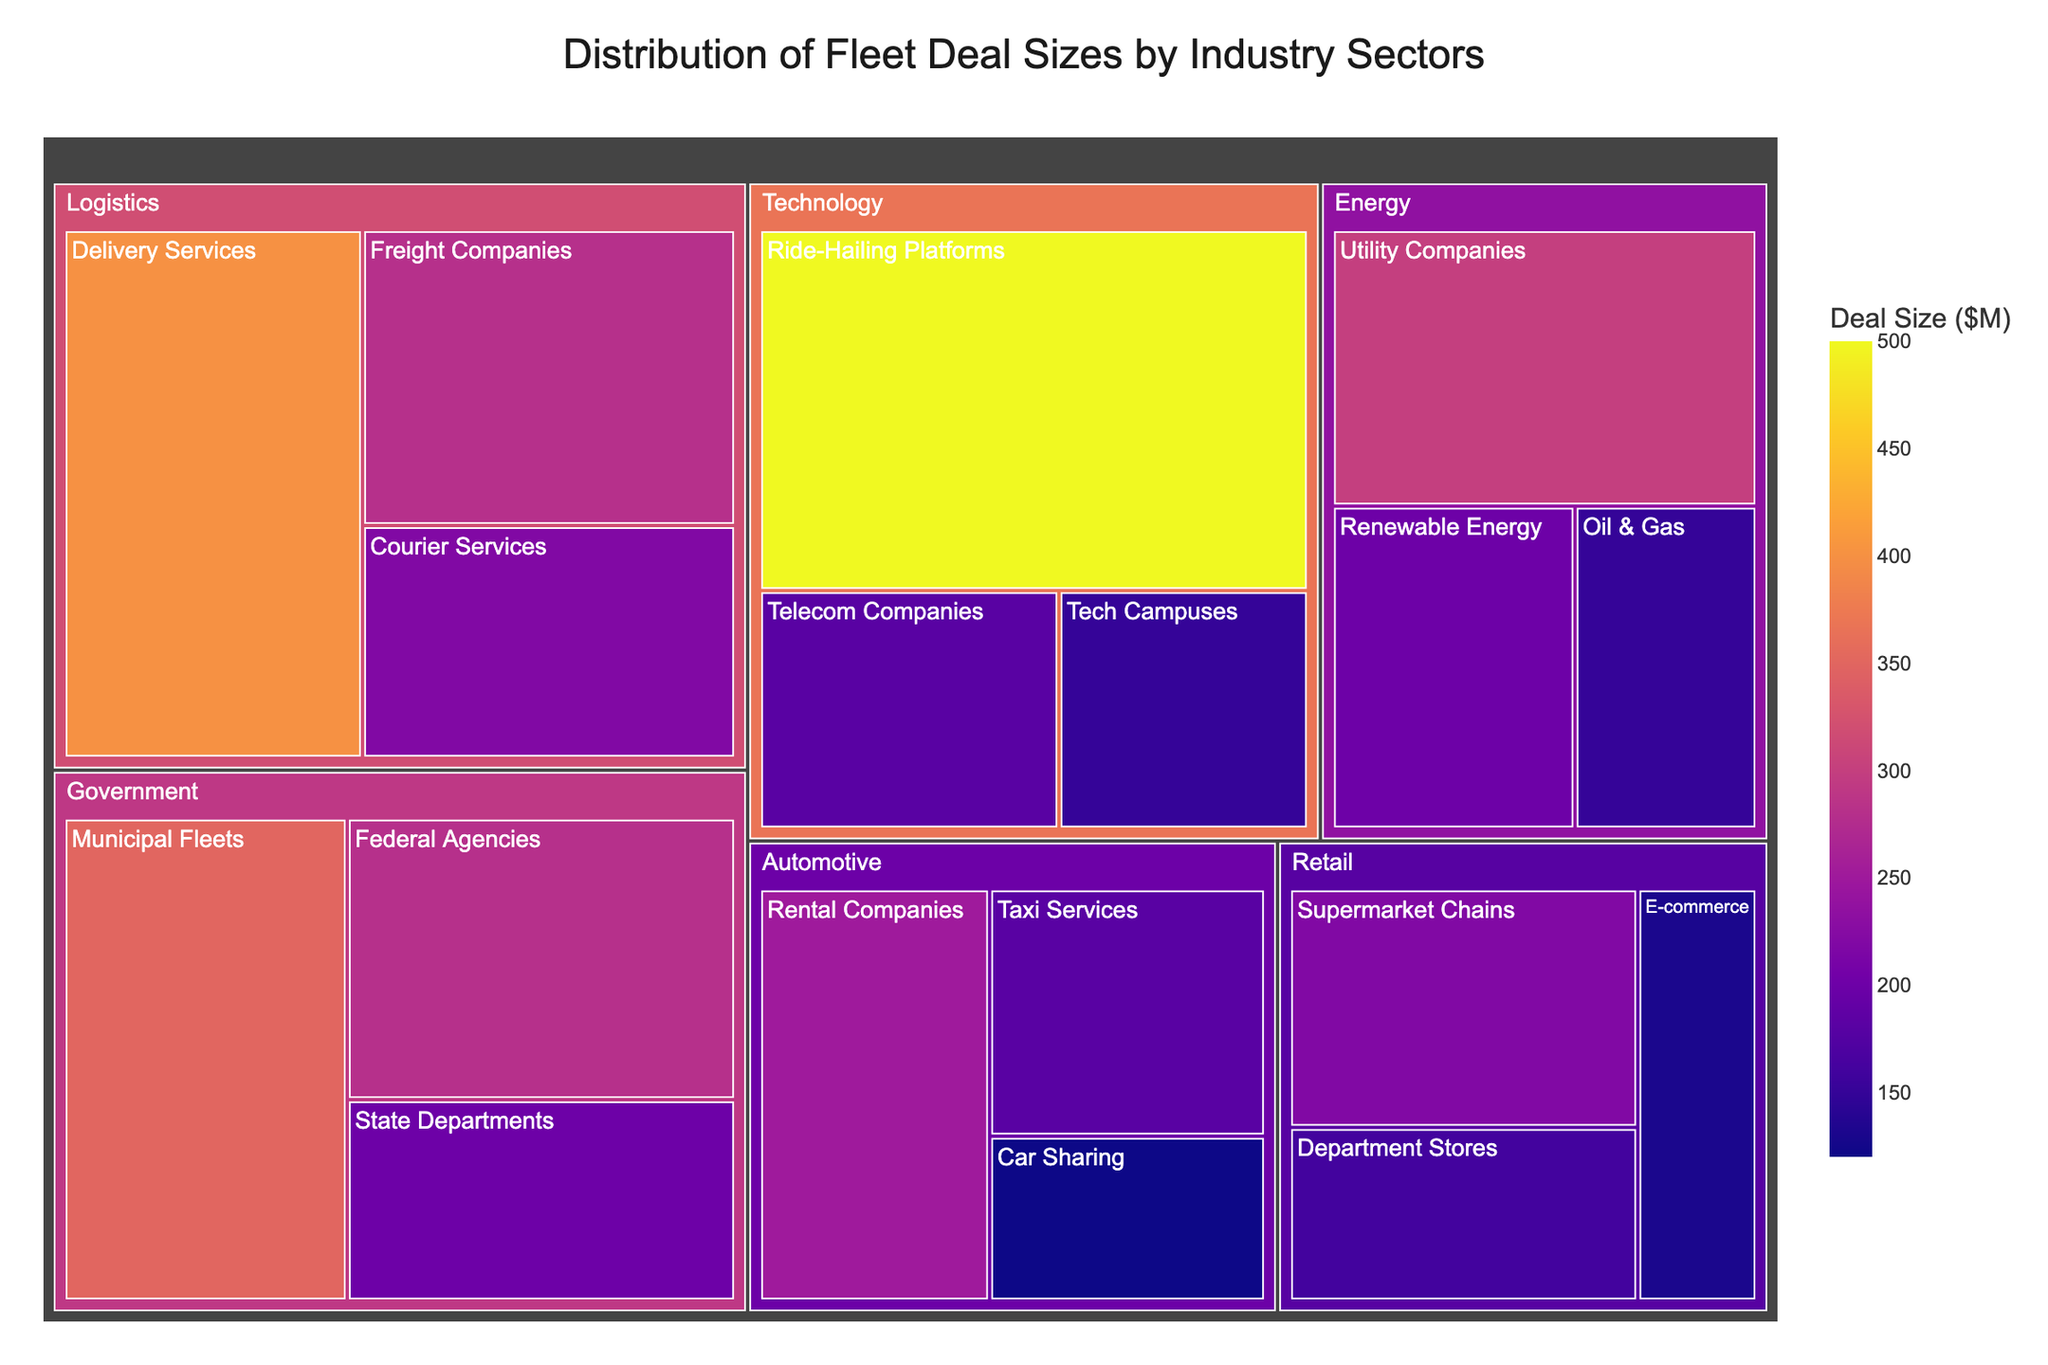How many industry sectors have a deal size greater than $200M? To answer this, examine the individual deal sizes in each sector across all industries. Count the number of sectors where the deal size exceeds $200M (Rental Companies, Utility Companies, Delivery Services, Municipal Fleets, Ride-Hailing Platforms).
Answer: 5 Which industry has the largest total deal size? Sum up the deal sizes of all sectors within each industry. Compare the totals to find the largest one. For example, add Rental Companies, Taxi Services, and Car Sharing for Automotive. Do this for all industries and compare (Automotive = 550, Energy = 650, Logistics = 900, Government = 830, Technology = 830, Retail = 510).
Answer: Logistics What's the smallest deal size in the figure? Identify the smallest value among all the deal sizes listed for each sector (Rental Companies, Taxi Services, etc.). The smallest value is 120M (Car Sharing).
Answer: 120 Which sector within the Government industry has the highest deal size? Look at the deal sizes within the Government industry (Municipal Fleets, Federal Agencies, State Departments) and identify the highest one. Municipal Fleets has the highest deal size of $350M.
Answer: Municipal Fleets Where does the Ride-Hailing Platforms sector fall in terms of deal size across all sectors? List all sectors along with their deal sizes, then locate Ride-Hailing Platforms. Compare its deal size ($500M) to rank it among the other sectors. It's the highest deal size among all sectors.
Answer: Highest What is the total deal size for Energy sectors combined? Sum up the deal sizes within the Energy industry: Utility Companies ($300M), Oil & Gas ($150M), and Renewable Energy ($200M). The combined total is 300 + 150 + 200 = 650.
Answer: 650 Which sector has the lowest deal size within the Automotive industry? Compare the deal sizes within the Automotive sectors (Rental Companies, Taxi Services, Car Sharing). Car Sharing has the lowest deal size of $120M.
Answer: Car Sharing How does the deal size of Logistics' Courier Services compare to Retail's Supermarket Chains? Compare the deal size of Courier Services ($220M) in Logistics with that of Supermarket Chains ($220M) in Retail. They are equal.
Answer: Equal What is the average deal size across all sectors in the Technology industry? Sum the deal sizes of all Technology sectors (Ride-Hailing Platforms, Tech Campuses, Telecom Companies). Divide by the number of sectors: (500 + 150 + 180) / 3. The average is (830 / 3) = 276.67.
Answer: 276.67 